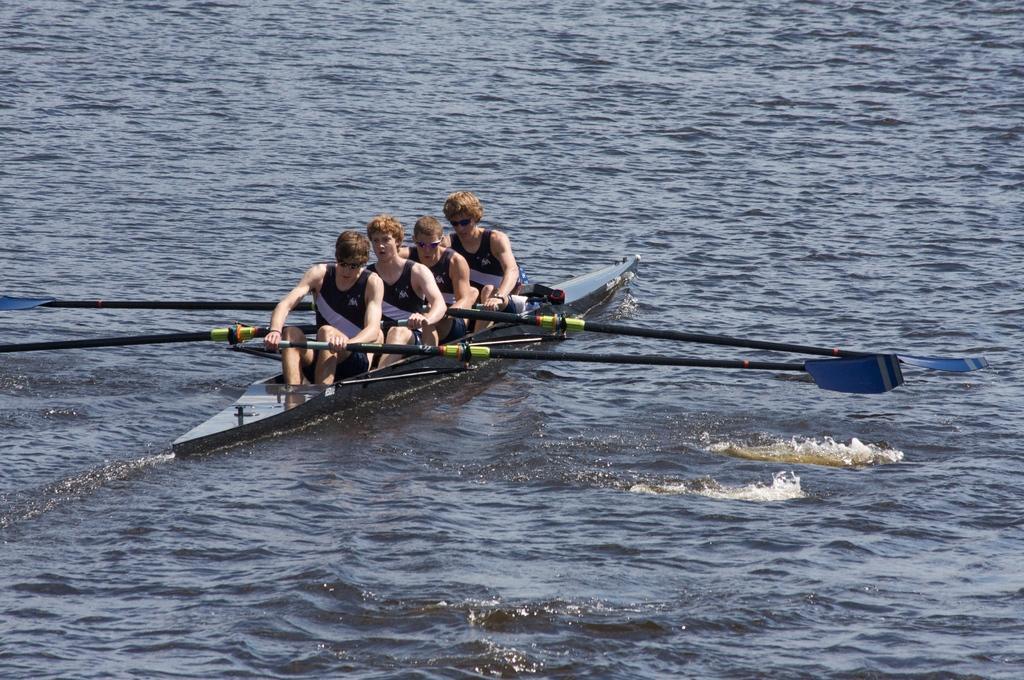Describe this image in one or two sentences. In this picture, we see four men rowing on the water. In the background, we see water and this water might be in the sea. 